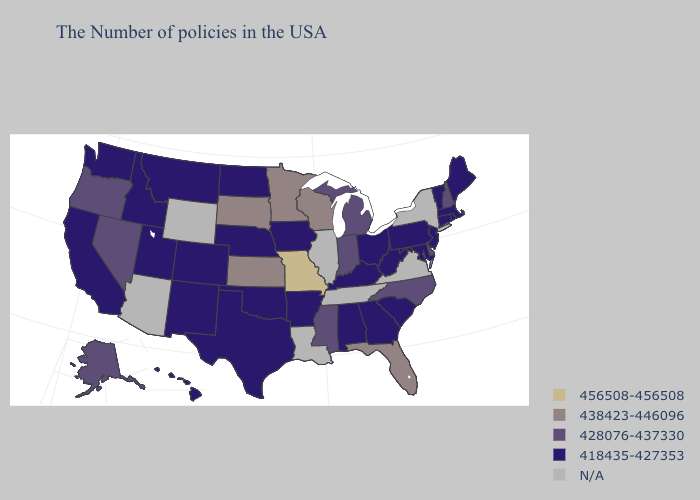Name the states that have a value in the range 418435-427353?
Be succinct. Maine, Massachusetts, Rhode Island, Vermont, Connecticut, New Jersey, Maryland, Pennsylvania, South Carolina, West Virginia, Ohio, Georgia, Kentucky, Alabama, Arkansas, Iowa, Nebraska, Oklahoma, Texas, North Dakota, Colorado, New Mexico, Utah, Montana, Idaho, California, Washington, Hawaii. Name the states that have a value in the range N/A?
Short answer required. New York, Virginia, Tennessee, Illinois, Louisiana, Wyoming, Arizona. What is the highest value in the USA?
Answer briefly. 456508-456508. What is the value of South Carolina?
Be succinct. 418435-427353. What is the highest value in the Northeast ?
Write a very short answer. 428076-437330. Which states have the lowest value in the South?
Short answer required. Maryland, South Carolina, West Virginia, Georgia, Kentucky, Alabama, Arkansas, Oklahoma, Texas. Among the states that border Texas , which have the highest value?
Concise answer only. Arkansas, Oklahoma, New Mexico. Among the states that border Michigan , does Wisconsin have the lowest value?
Answer briefly. No. Name the states that have a value in the range 428076-437330?
Give a very brief answer. New Hampshire, Delaware, North Carolina, Michigan, Indiana, Mississippi, Nevada, Oregon, Alaska. Name the states that have a value in the range 428076-437330?
Give a very brief answer. New Hampshire, Delaware, North Carolina, Michigan, Indiana, Mississippi, Nevada, Oregon, Alaska. Name the states that have a value in the range 428076-437330?
Be succinct. New Hampshire, Delaware, North Carolina, Michigan, Indiana, Mississippi, Nevada, Oregon, Alaska. What is the value of Florida?
Keep it brief. 438423-446096. What is the lowest value in the USA?
Keep it brief. 418435-427353. 